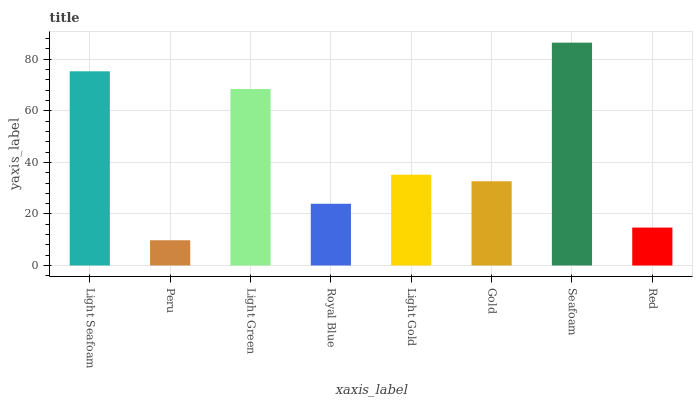Is Light Green the minimum?
Answer yes or no. No. Is Light Green the maximum?
Answer yes or no. No. Is Light Green greater than Peru?
Answer yes or no. Yes. Is Peru less than Light Green?
Answer yes or no. Yes. Is Peru greater than Light Green?
Answer yes or no. No. Is Light Green less than Peru?
Answer yes or no. No. Is Light Gold the high median?
Answer yes or no. Yes. Is Gold the low median?
Answer yes or no. Yes. Is Royal Blue the high median?
Answer yes or no. No. Is Red the low median?
Answer yes or no. No. 